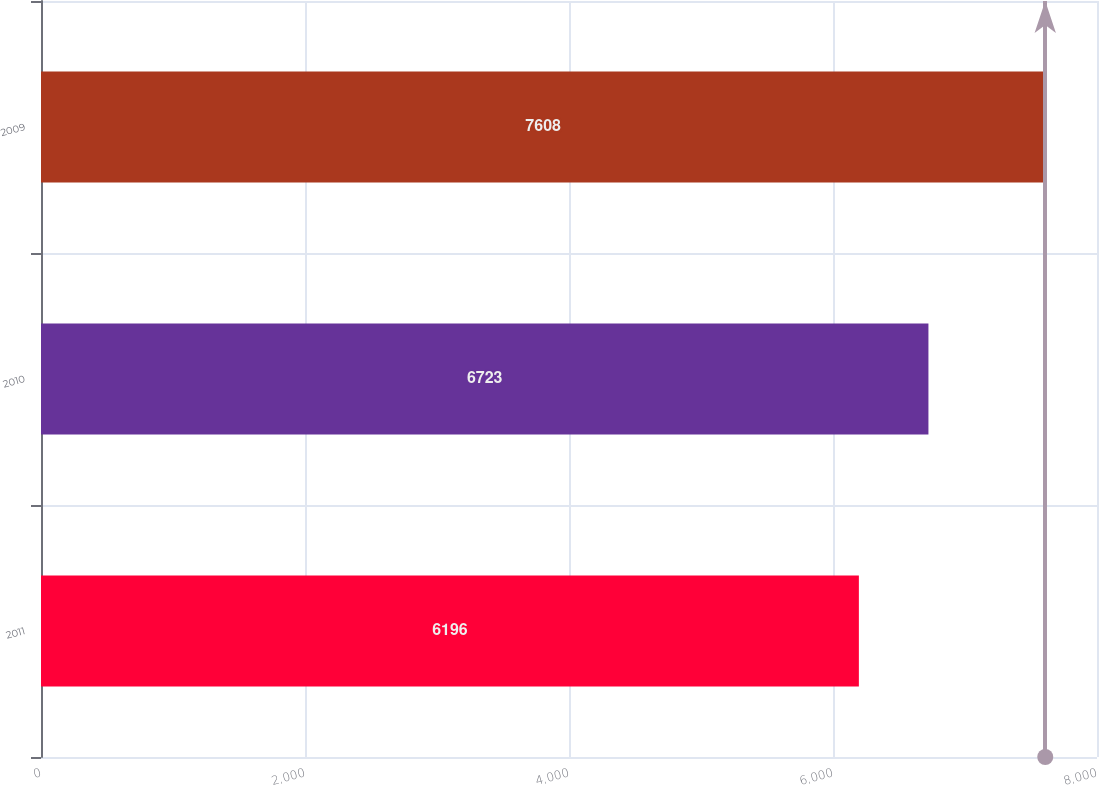Convert chart to OTSL. <chart><loc_0><loc_0><loc_500><loc_500><bar_chart><fcel>2011<fcel>2010<fcel>2009<nl><fcel>6196<fcel>6723<fcel>7608<nl></chart> 